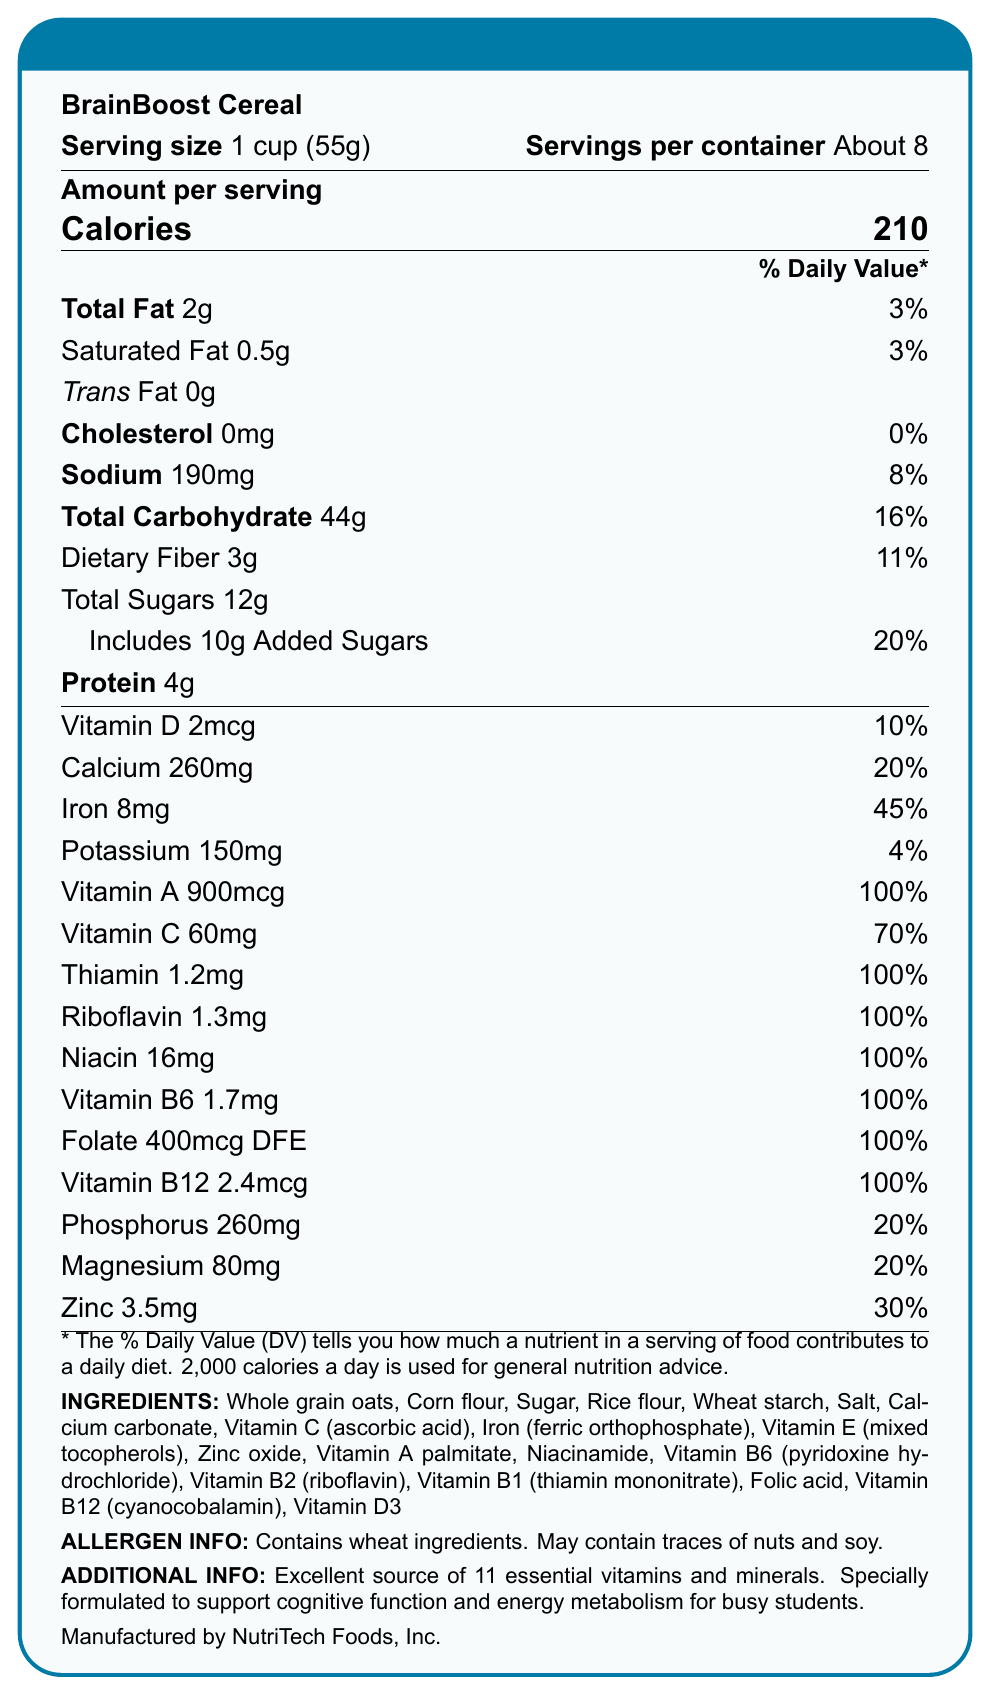what is the total fat per serving? The document states that there are 2 grams of total fat per serving.
Answer: 2g how much dietary fiber is in one serving? The document specifies that there are 3 grams of dietary fiber per serving.
Answer: 3g what is the serving size for BrainBoost Cereal? According to the document, the serving size is 1 cup, which is equivalent to 55 grams.
Answer: 1 cup (55g) what is the percentage of daily value of iron per serving? The document indicates that the daily value percentage for iron per serving is 45%.
Answer: 45% how many grams of added sugars are in one serving? The document notes that each serving includes 10 grams of added sugars.
Answer: 10g which vitamin is present at 100% of the daily value in BrainBoost Cereal? A. Vitamin D B. Vitamin A C. Vitamin C D. Vitamin B6 The document shows that Vitamin A is present at 100% of the daily value.
Answer: B how many servings per container of BrainBoost Cereal? A. About 6 B. About 8 C. About 10 D. About 12 The document states that there are about 8 servings per container.
Answer: B does this cereal contain cholesterol? The document lists the cholesterol amount as 0mg, indicating there is no cholesterol in the cereal.
Answer: No can BrainBoost Cereal help with energy metabolism? The document mentions that it is specially formulated to support cognitive function and energy metabolism for busy students.
Answer: Yes based on the document, which nutrients are present in amounts greater than 20% of the daily value per serving? The document provides the daily value percentages, and the aforementioned nutrients are all present in amounts greater than 20% of the daily value per serving.
Answer: Iron, Vitamin A, Vitamin C, Thiamin, Riboflavin, Niacin, Vitamin B6, Folate, Vitamin B12, Calcium, Phosphorus, Magnesium, Zinc describe the main idea of the document. This comprehensive summary encapsulates the detailed nutrition information, health benefits, and additional attributes of BrainBoost Cereal as described in the document.
Answer: The document presents the nutrition facts for BrainBoost Cereal, detailing the serving size, calories, macronutrients, and the amounts and daily values of various vitamins and minerals. It highlights its nutritional benefits, especially its support for cognitive function and energy metabolism, and provides information about the ingredients, allergen info, and the manufacturer. what is the annual revenue of NutriTech Foods, Inc.? The document does not provide any financial details or revenue information about NutriTech Foods, Inc.
Answer: Not enough information 